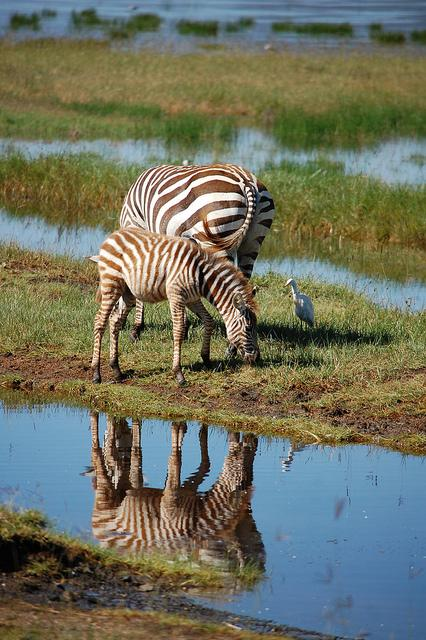Which animal is in danger from the other here? bird 